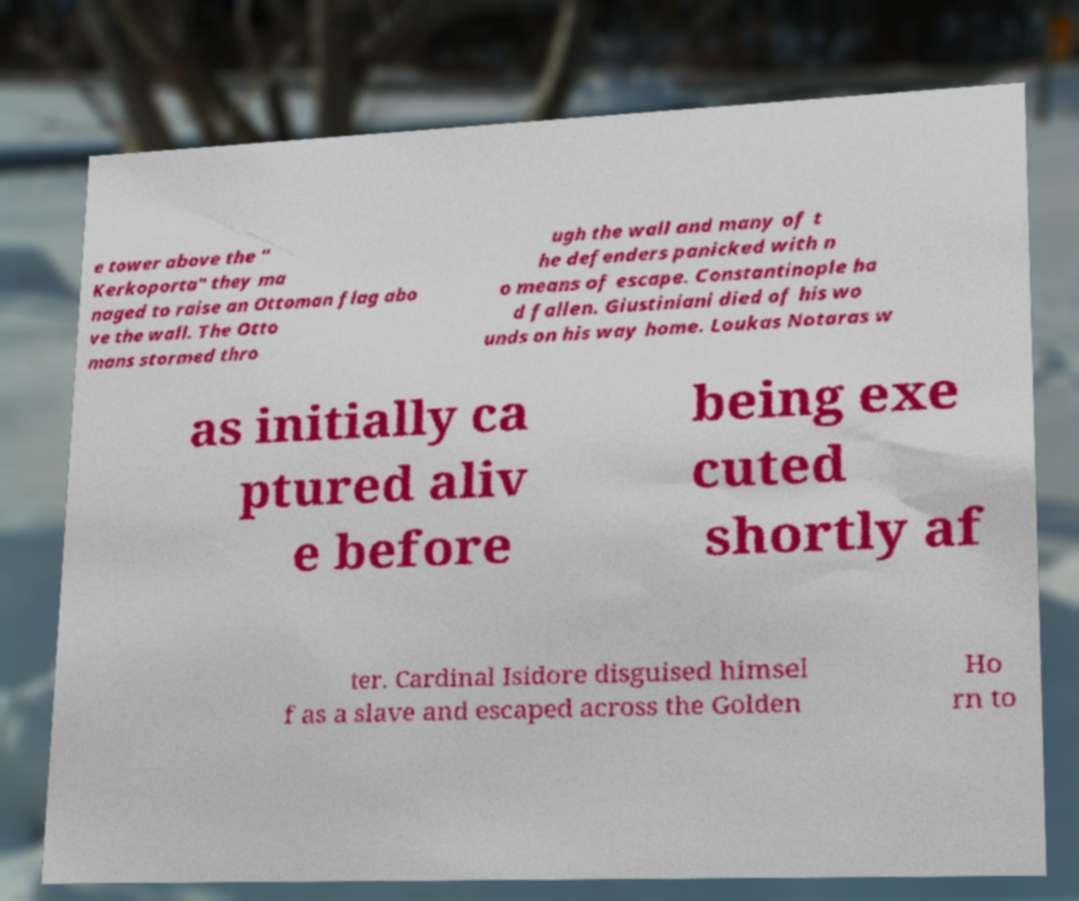There's text embedded in this image that I need extracted. Can you transcribe it verbatim? e tower above the " Kerkoporta" they ma naged to raise an Ottoman flag abo ve the wall. The Otto mans stormed thro ugh the wall and many of t he defenders panicked with n o means of escape. Constantinople ha d fallen. Giustiniani died of his wo unds on his way home. Loukas Notaras w as initially ca ptured aliv e before being exe cuted shortly af ter. Cardinal Isidore disguised himsel f as a slave and escaped across the Golden Ho rn to 